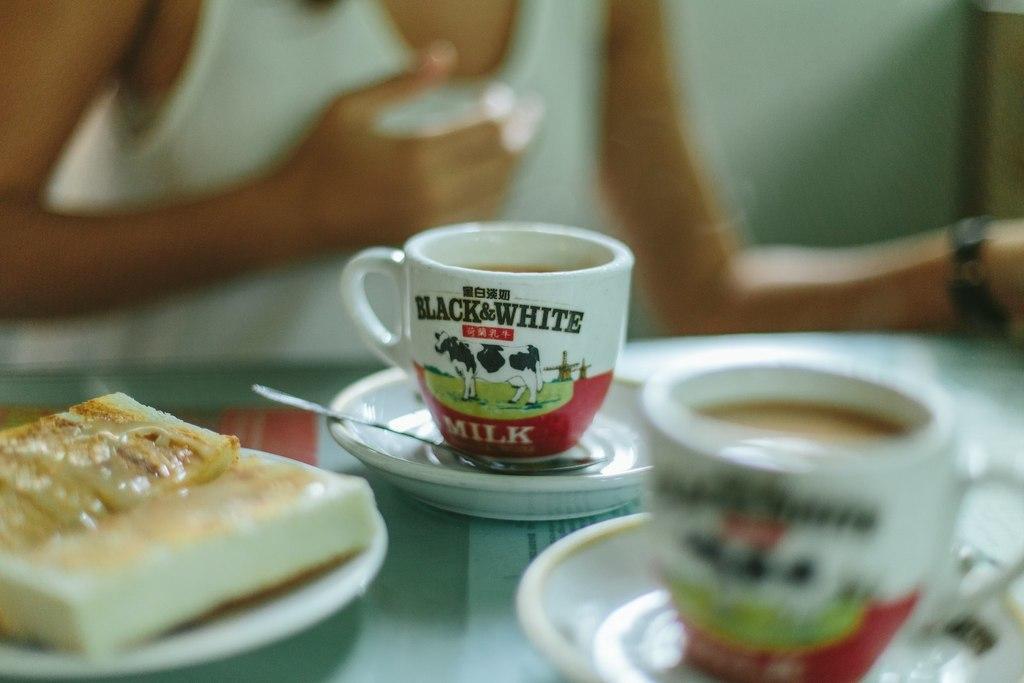How would you summarize this image in a sentence or two? In this image, we can see a table contains plate with some food and cups with saucers. In the background, we can see a person whose face is not visible. 